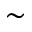<formula> <loc_0><loc_0><loc_500><loc_500>\sim</formula> 